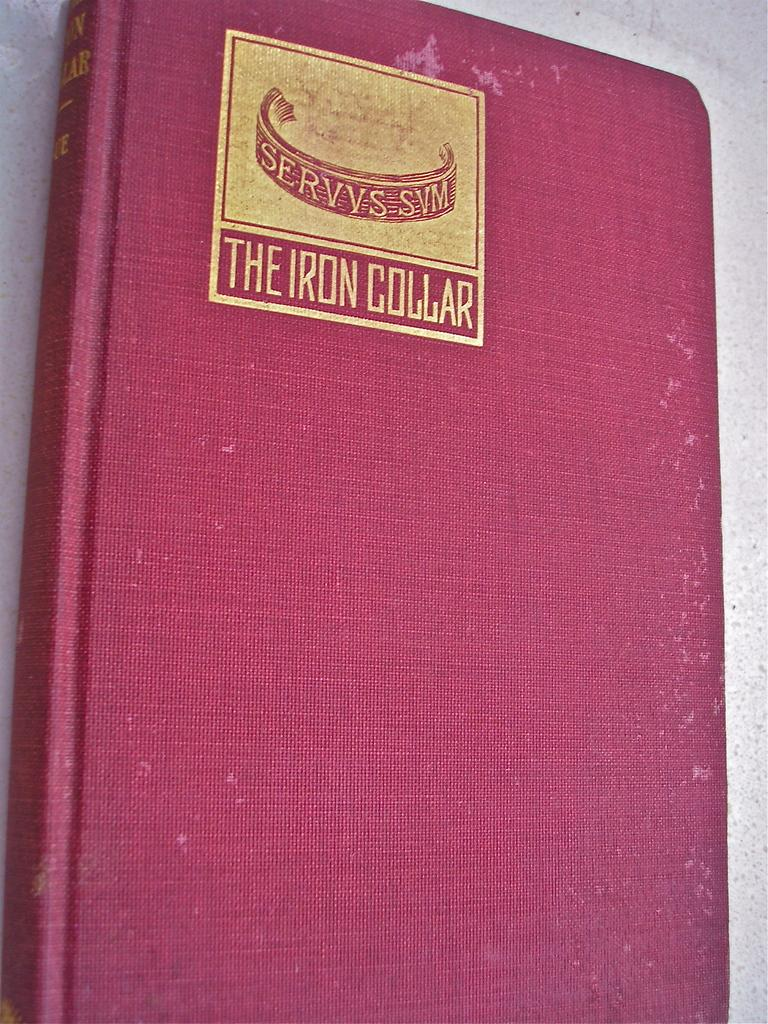Provide a one-sentence caption for the provided image. A red notebook has an emblem that says THE IRON COLLAR on it. 